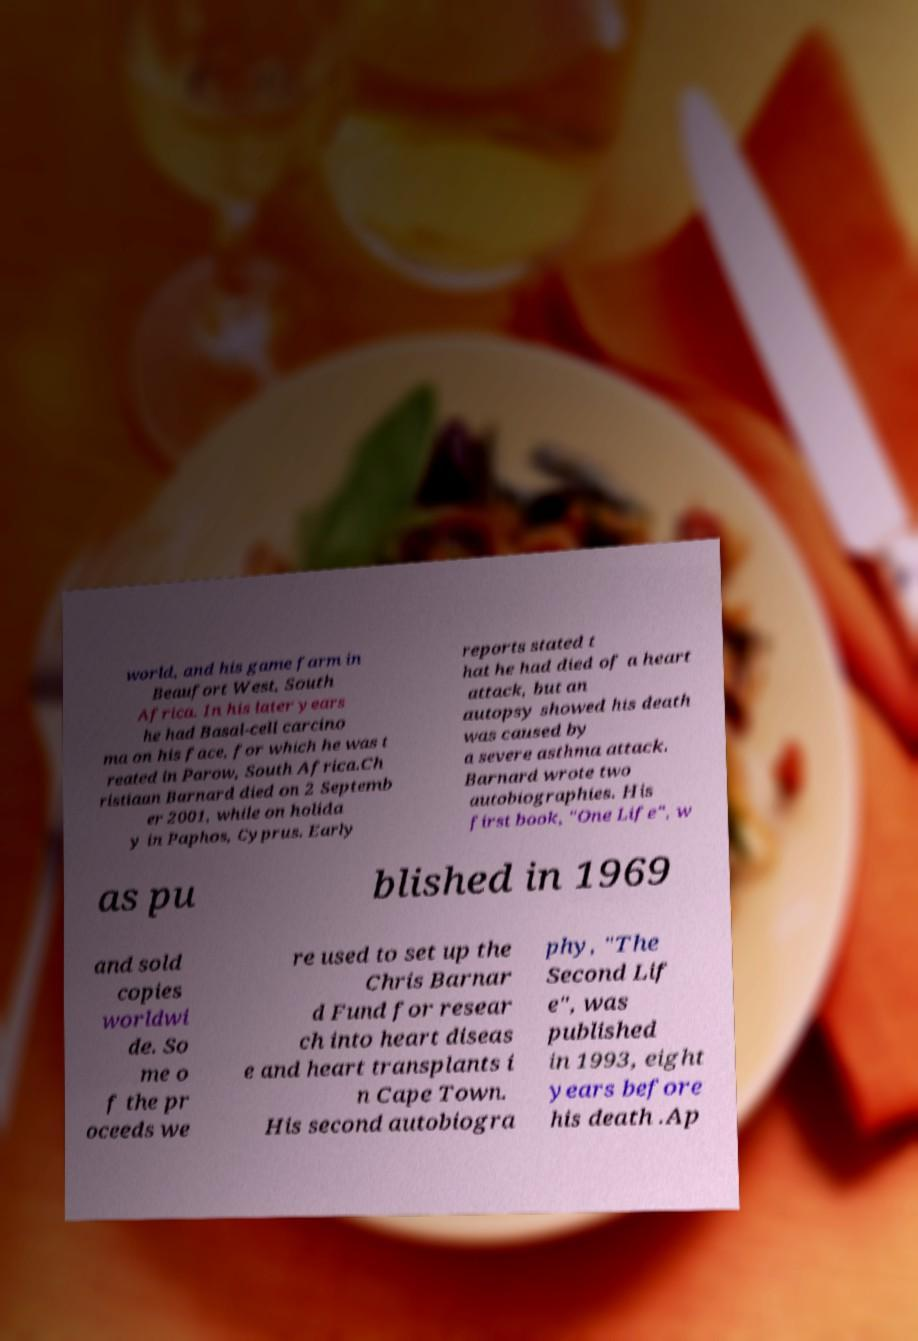For documentation purposes, I need the text within this image transcribed. Could you provide that? world, and his game farm in Beaufort West, South Africa. In his later years he had Basal-cell carcino ma on his face, for which he was t reated in Parow, South Africa.Ch ristiaan Barnard died on 2 Septemb er 2001, while on holida y in Paphos, Cyprus. Early reports stated t hat he had died of a heart attack, but an autopsy showed his death was caused by a severe asthma attack. Barnard wrote two autobiographies. His first book, "One Life", w as pu blished in 1969 and sold copies worldwi de. So me o f the pr oceeds we re used to set up the Chris Barnar d Fund for resear ch into heart diseas e and heart transplants i n Cape Town. His second autobiogra phy, "The Second Lif e", was published in 1993, eight years before his death .Ap 